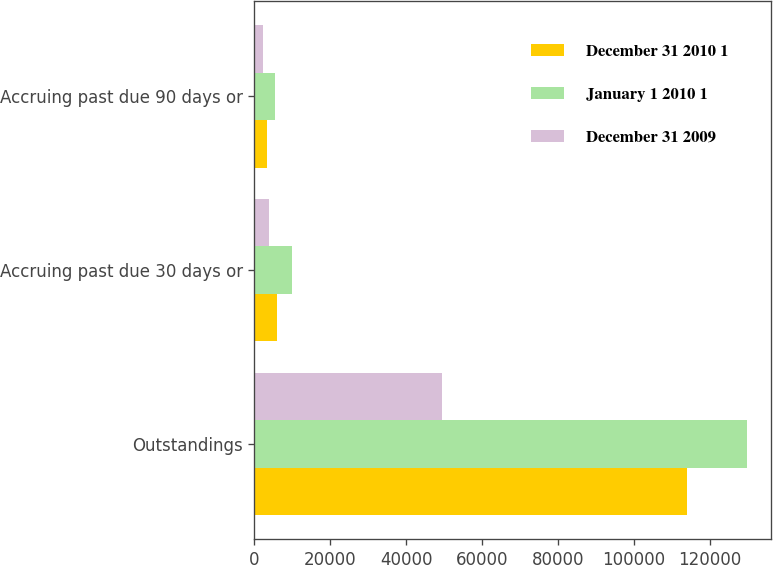<chart> <loc_0><loc_0><loc_500><loc_500><stacked_bar_chart><ecel><fcel>Outstandings<fcel>Accruing past due 30 days or<fcel>Accruing past due 90 days or<nl><fcel>December 31 2010 1<fcel>113785<fcel>5913<fcel>3320<nl><fcel>January 1 2010 1<fcel>129642<fcel>9866<fcel>5408<nl><fcel>December 31 2009<fcel>49453<fcel>3907<fcel>2158<nl></chart> 